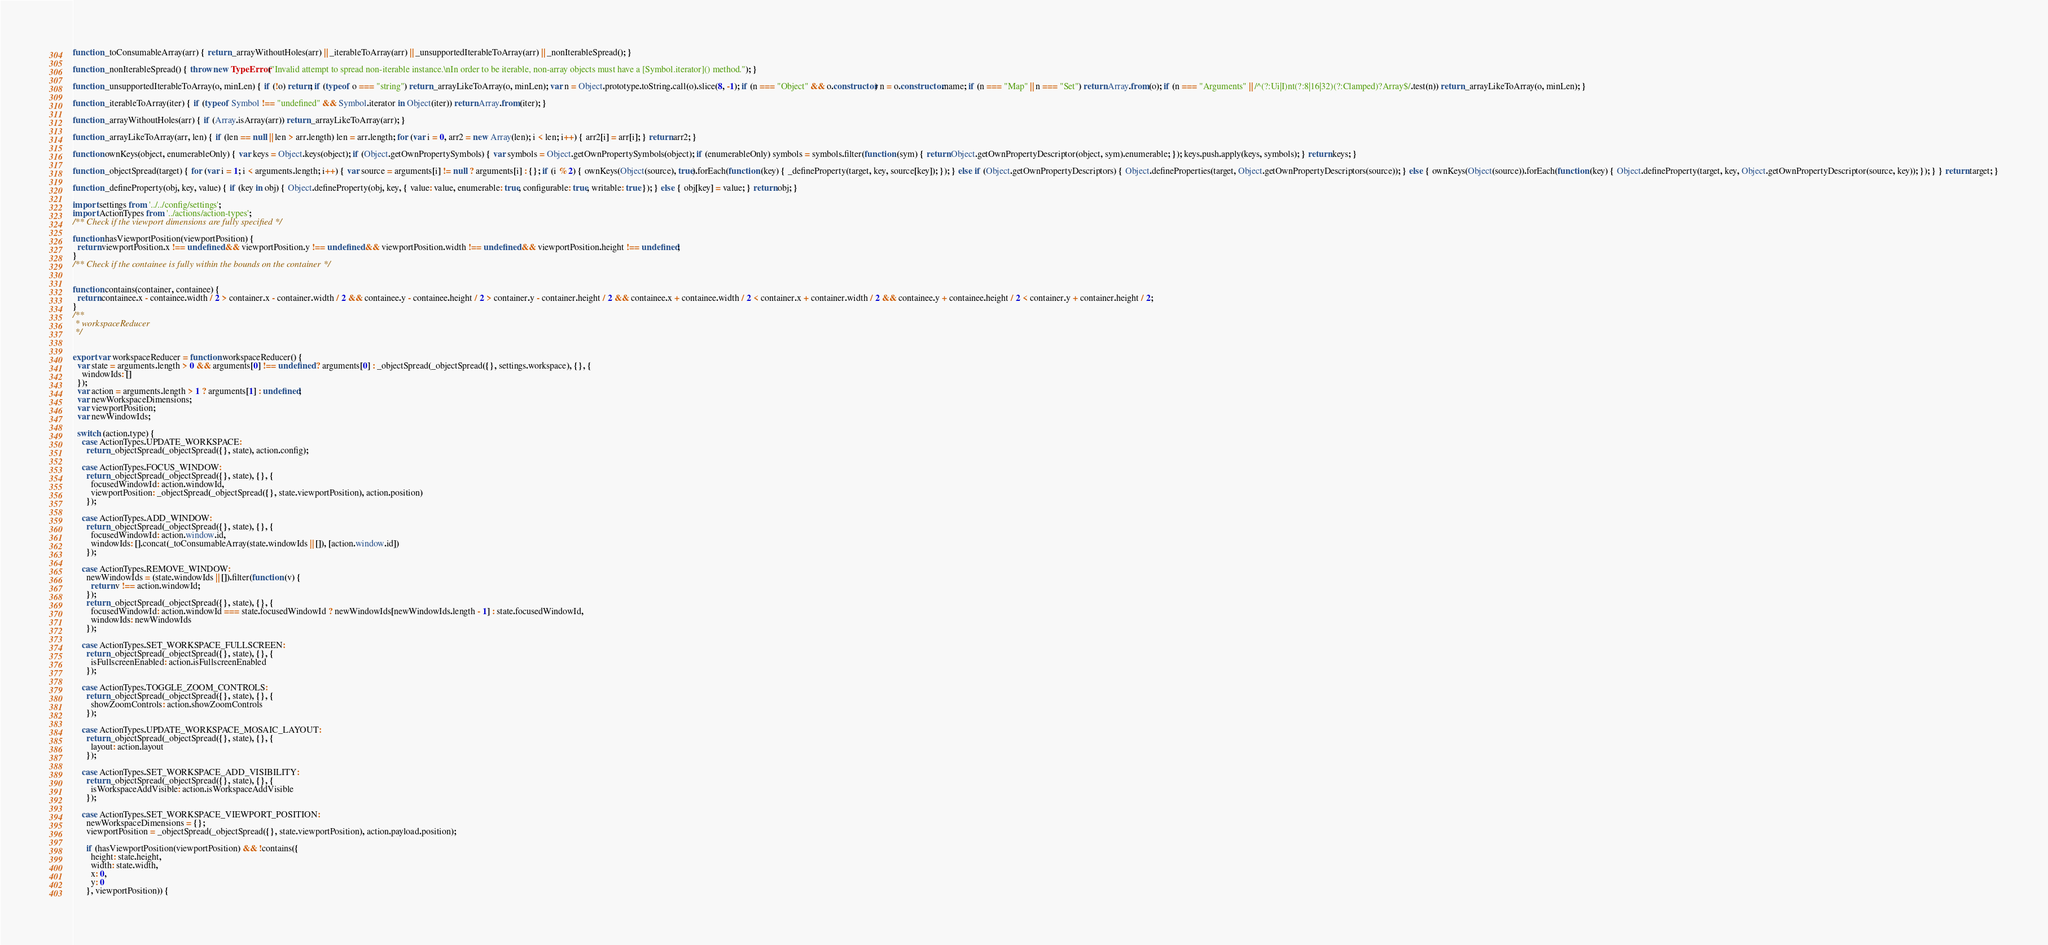Convert code to text. <code><loc_0><loc_0><loc_500><loc_500><_JavaScript_>function _toConsumableArray(arr) { return _arrayWithoutHoles(arr) || _iterableToArray(arr) || _unsupportedIterableToArray(arr) || _nonIterableSpread(); }

function _nonIterableSpread() { throw new TypeError("Invalid attempt to spread non-iterable instance.\nIn order to be iterable, non-array objects must have a [Symbol.iterator]() method."); }

function _unsupportedIterableToArray(o, minLen) { if (!o) return; if (typeof o === "string") return _arrayLikeToArray(o, minLen); var n = Object.prototype.toString.call(o).slice(8, -1); if (n === "Object" && o.constructor) n = o.constructor.name; if (n === "Map" || n === "Set") return Array.from(o); if (n === "Arguments" || /^(?:Ui|I)nt(?:8|16|32)(?:Clamped)?Array$/.test(n)) return _arrayLikeToArray(o, minLen); }

function _iterableToArray(iter) { if (typeof Symbol !== "undefined" && Symbol.iterator in Object(iter)) return Array.from(iter); }

function _arrayWithoutHoles(arr) { if (Array.isArray(arr)) return _arrayLikeToArray(arr); }

function _arrayLikeToArray(arr, len) { if (len == null || len > arr.length) len = arr.length; for (var i = 0, arr2 = new Array(len); i < len; i++) { arr2[i] = arr[i]; } return arr2; }

function ownKeys(object, enumerableOnly) { var keys = Object.keys(object); if (Object.getOwnPropertySymbols) { var symbols = Object.getOwnPropertySymbols(object); if (enumerableOnly) symbols = symbols.filter(function (sym) { return Object.getOwnPropertyDescriptor(object, sym).enumerable; }); keys.push.apply(keys, symbols); } return keys; }

function _objectSpread(target) { for (var i = 1; i < arguments.length; i++) { var source = arguments[i] != null ? arguments[i] : {}; if (i % 2) { ownKeys(Object(source), true).forEach(function (key) { _defineProperty(target, key, source[key]); }); } else if (Object.getOwnPropertyDescriptors) { Object.defineProperties(target, Object.getOwnPropertyDescriptors(source)); } else { ownKeys(Object(source)).forEach(function (key) { Object.defineProperty(target, key, Object.getOwnPropertyDescriptor(source, key)); }); } } return target; }

function _defineProperty(obj, key, value) { if (key in obj) { Object.defineProperty(obj, key, { value: value, enumerable: true, configurable: true, writable: true }); } else { obj[key] = value; } return obj; }

import settings from '../../config/settings';
import ActionTypes from '../actions/action-types';
/** Check if the viewport dimensions are fully specified */

function hasViewportPosition(viewportPosition) {
  return viewportPosition.x !== undefined && viewportPosition.y !== undefined && viewportPosition.width !== undefined && viewportPosition.height !== undefined;
}
/** Check if the containee is fully within the bounds on the container */


function contains(container, containee) {
  return containee.x - containee.width / 2 > container.x - container.width / 2 && containee.y - containee.height / 2 > container.y - container.height / 2 && containee.x + containee.width / 2 < container.x + container.width / 2 && containee.y + containee.height / 2 < container.y + container.height / 2;
}
/**
 * workspaceReducer
 */


export var workspaceReducer = function workspaceReducer() {
  var state = arguments.length > 0 && arguments[0] !== undefined ? arguments[0] : _objectSpread(_objectSpread({}, settings.workspace), {}, {
    windowIds: []
  });
  var action = arguments.length > 1 ? arguments[1] : undefined;
  var newWorkspaceDimensions;
  var viewportPosition;
  var newWindowIds;

  switch (action.type) {
    case ActionTypes.UPDATE_WORKSPACE:
      return _objectSpread(_objectSpread({}, state), action.config);

    case ActionTypes.FOCUS_WINDOW:
      return _objectSpread(_objectSpread({}, state), {}, {
        focusedWindowId: action.windowId,
        viewportPosition: _objectSpread(_objectSpread({}, state.viewportPosition), action.position)
      });

    case ActionTypes.ADD_WINDOW:
      return _objectSpread(_objectSpread({}, state), {}, {
        focusedWindowId: action.window.id,
        windowIds: [].concat(_toConsumableArray(state.windowIds || []), [action.window.id])
      });

    case ActionTypes.REMOVE_WINDOW:
      newWindowIds = (state.windowIds || []).filter(function (v) {
        return v !== action.windowId;
      });
      return _objectSpread(_objectSpread({}, state), {}, {
        focusedWindowId: action.windowId === state.focusedWindowId ? newWindowIds[newWindowIds.length - 1] : state.focusedWindowId,
        windowIds: newWindowIds
      });

    case ActionTypes.SET_WORKSPACE_FULLSCREEN:
      return _objectSpread(_objectSpread({}, state), {}, {
        isFullscreenEnabled: action.isFullscreenEnabled
      });

    case ActionTypes.TOGGLE_ZOOM_CONTROLS:
      return _objectSpread(_objectSpread({}, state), {}, {
        showZoomControls: action.showZoomControls
      });

    case ActionTypes.UPDATE_WORKSPACE_MOSAIC_LAYOUT:
      return _objectSpread(_objectSpread({}, state), {}, {
        layout: action.layout
      });

    case ActionTypes.SET_WORKSPACE_ADD_VISIBILITY:
      return _objectSpread(_objectSpread({}, state), {}, {
        isWorkspaceAddVisible: action.isWorkspaceAddVisible
      });

    case ActionTypes.SET_WORKSPACE_VIEWPORT_POSITION:
      newWorkspaceDimensions = {};
      viewportPosition = _objectSpread(_objectSpread({}, state.viewportPosition), action.payload.position);

      if (hasViewportPosition(viewportPosition) && !contains({
        height: state.height,
        width: state.width,
        x: 0,
        y: 0
      }, viewportPosition)) {</code> 